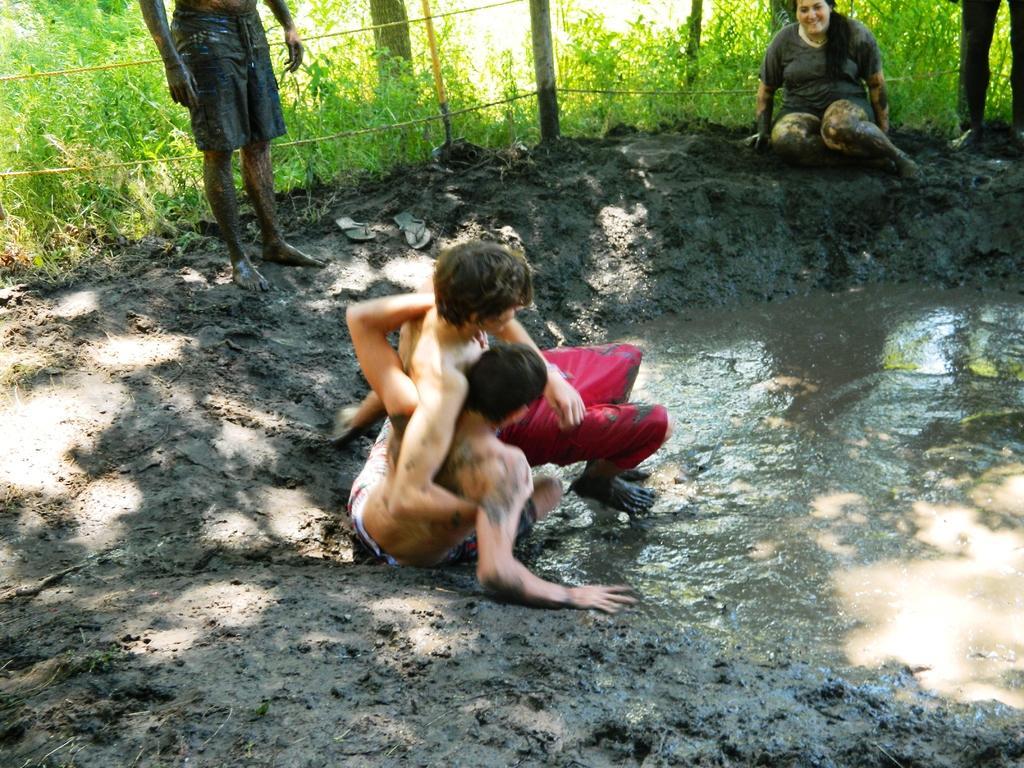Describe this image in one or two sentences. In the center of the image, we can see two people fighting and in the background, there are some other people and we can see a fence and tree trunks and there is grass. At the bottom, there is mud with water. 